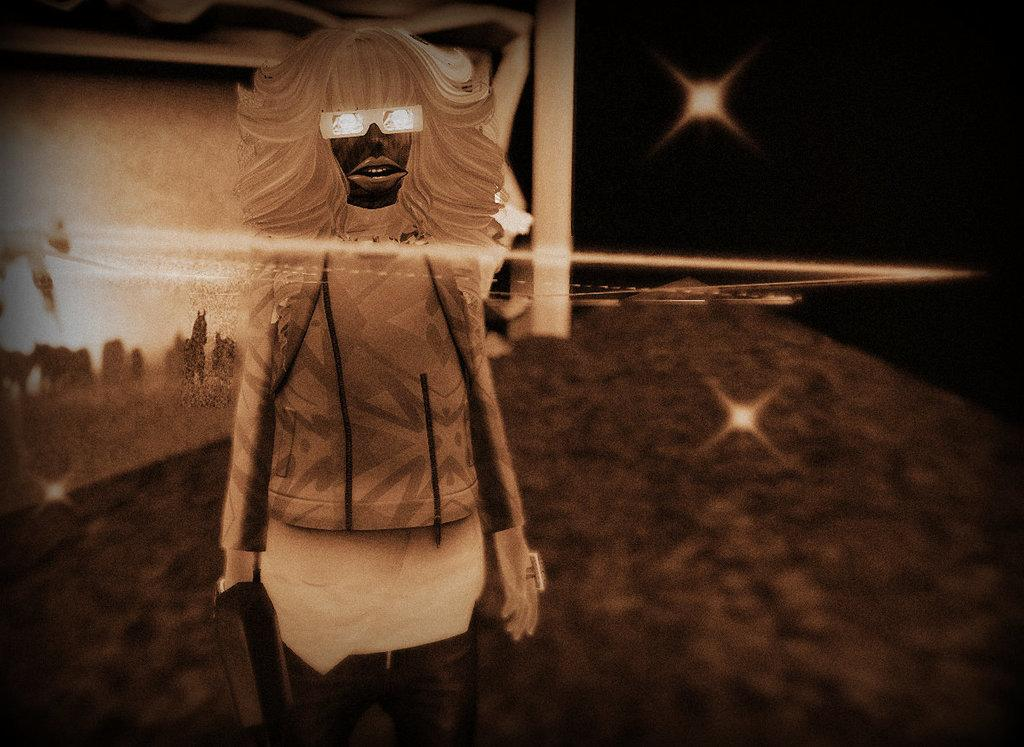What is the main subject of the image? There is an animated image of a woman standing in the picture. What is behind the woman in the image? There is a wall behind the woman. What can be seen in the sky in the image? Two stars are shining in the dark, beside the wall. Where is the nearest airport to the woman in the image? The provided facts do not mention an airport, so it cannot be determined from the image. 